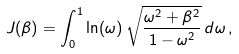<formula> <loc_0><loc_0><loc_500><loc_500>J ( \beta ) = \int _ { 0 } ^ { 1 } \ln ( \omega ) \, \sqrt { \frac { \omega ^ { 2 } + \beta ^ { 2 } } { 1 - \omega ^ { 2 } } } \, { d } \omega \, ,</formula> 